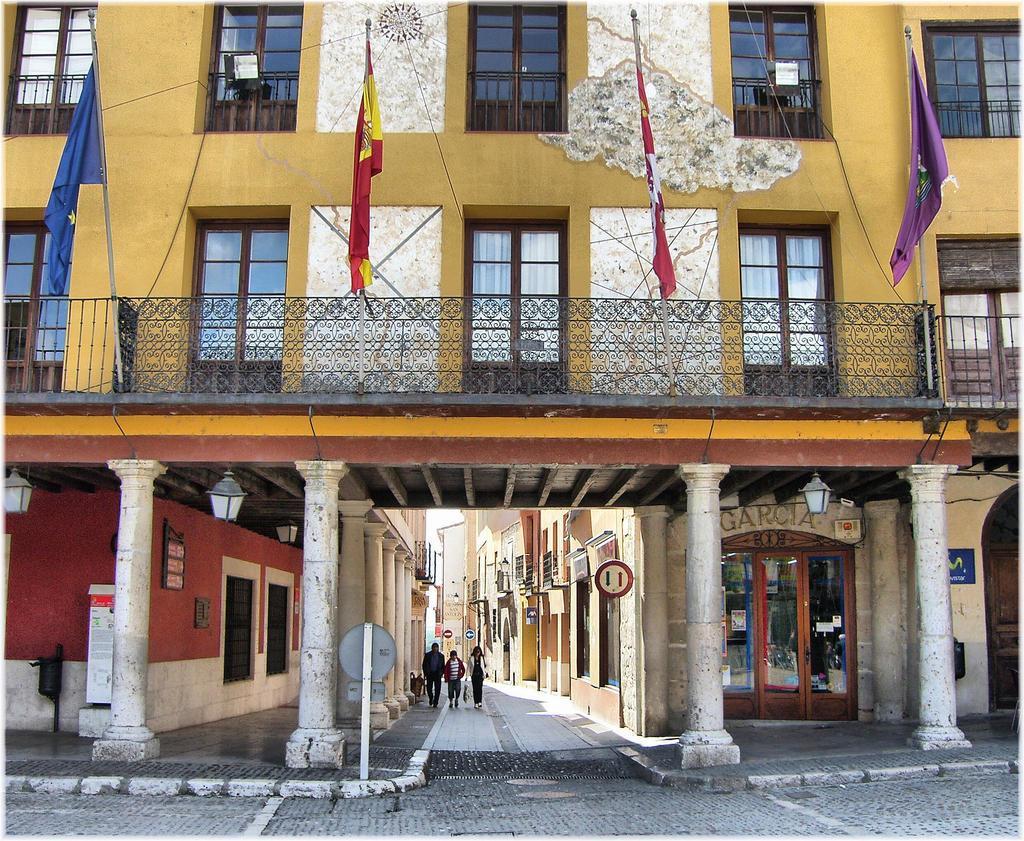Please provide a concise description of this image. In this picture we can see buildings,here we can see people walking on the ground,sign board,posters,lanterns,fence,pillars and flags. 